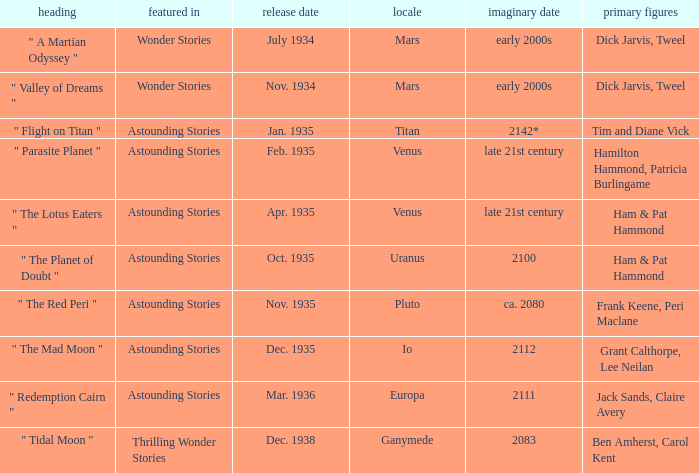Name the publication date when the fictional date is 2112 Dec. 1935. 